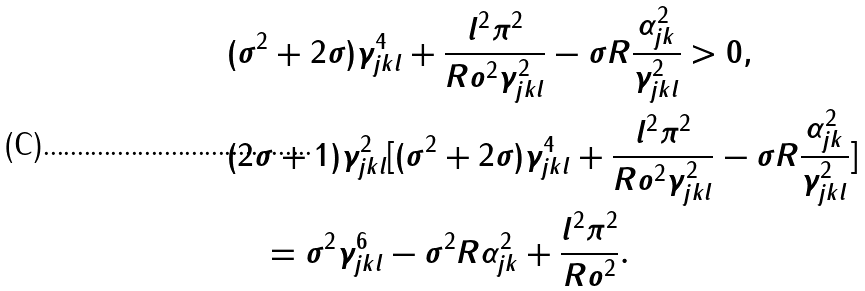Convert formula to latex. <formula><loc_0><loc_0><loc_500><loc_500>& ( \sigma ^ { 2 } + 2 \sigma ) \gamma _ { j k l } ^ { 4 } + \frac { l ^ { 2 } \pi ^ { 2 } } { R o ^ { 2 } \gamma _ { j k l } ^ { 2 } } - \sigma R \frac { \alpha _ { j k } ^ { 2 } } { \gamma _ { j k l } ^ { 2 } } > 0 , \\ & ( 2 \sigma + 1 ) \gamma _ { j k l } ^ { 2 } [ ( \sigma ^ { 2 } + 2 \sigma ) \gamma _ { j k l } ^ { 4 } + \frac { l ^ { 2 } \pi ^ { 2 } } { R o ^ { 2 } \gamma _ { j k l } ^ { 2 } } - \sigma R \frac { \alpha _ { j k } ^ { 2 } } { \gamma _ { j k l } ^ { 2 } } ] \\ & \quad = \sigma ^ { 2 } \gamma _ { j k l } ^ { 6 } - \sigma ^ { 2 } R \alpha _ { j k } ^ { 2 } + \frac { l ^ { 2 } \pi ^ { 2 } } { R o ^ { 2 } } .</formula> 